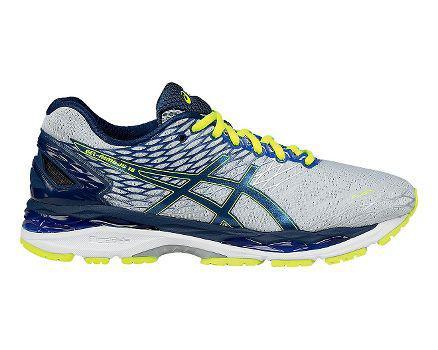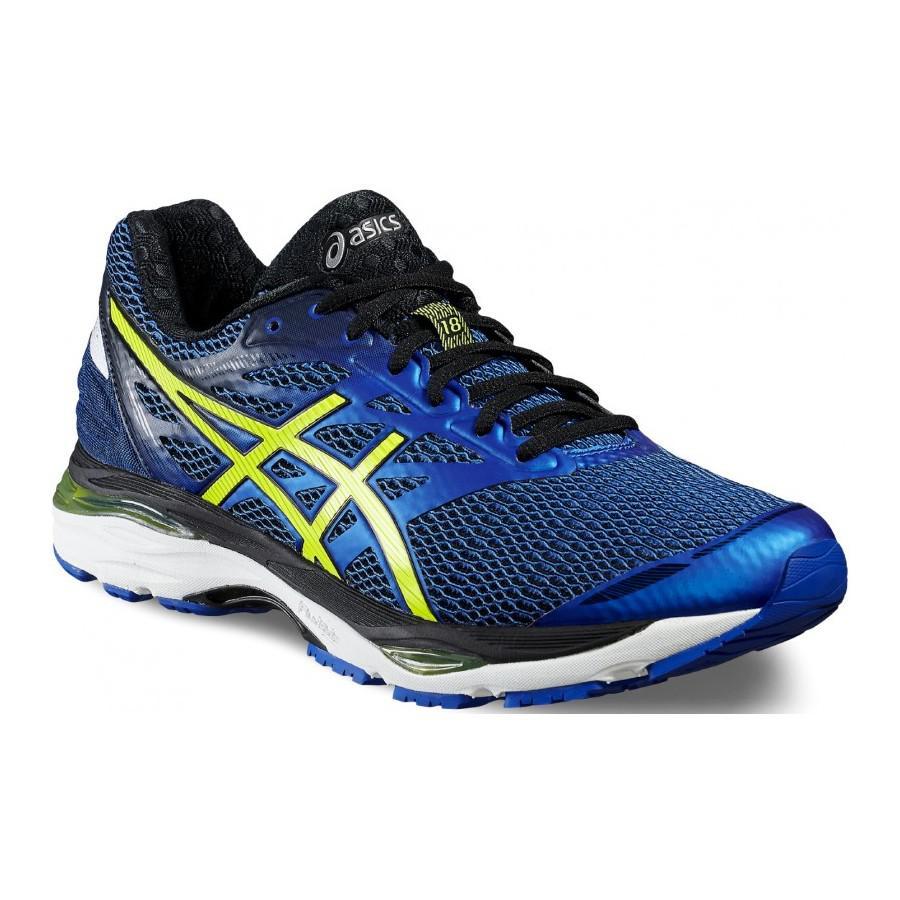The first image is the image on the left, the second image is the image on the right. Evaluate the accuracy of this statement regarding the images: "Each image shows one shoe with blue in its color scheme, and all shoes face rightward.". Is it true? Answer yes or no. Yes. The first image is the image on the left, the second image is the image on the right. Analyze the images presented: Is the assertion "Both shoes have the same logo across the side." valid? Answer yes or no. Yes. 